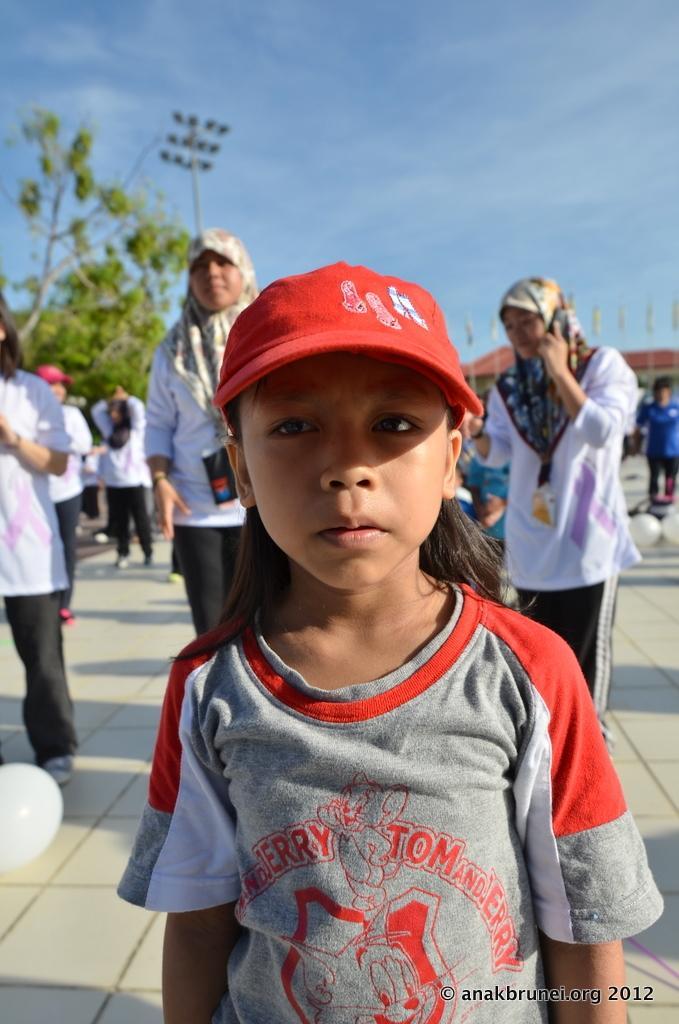Can you describe this image briefly? In this image there is a girl standing, she is wearing a cap, there are group of persons standing, there is a woman holding a mobile phone, there are balloons on the ground, there is a tree towards the left of the image, there is a pole, there are lights, there is a building towards the right of the image, there is a flag towards the right of the image, there is text towards the bottom of the image, there is the sky towards the top of the image. 